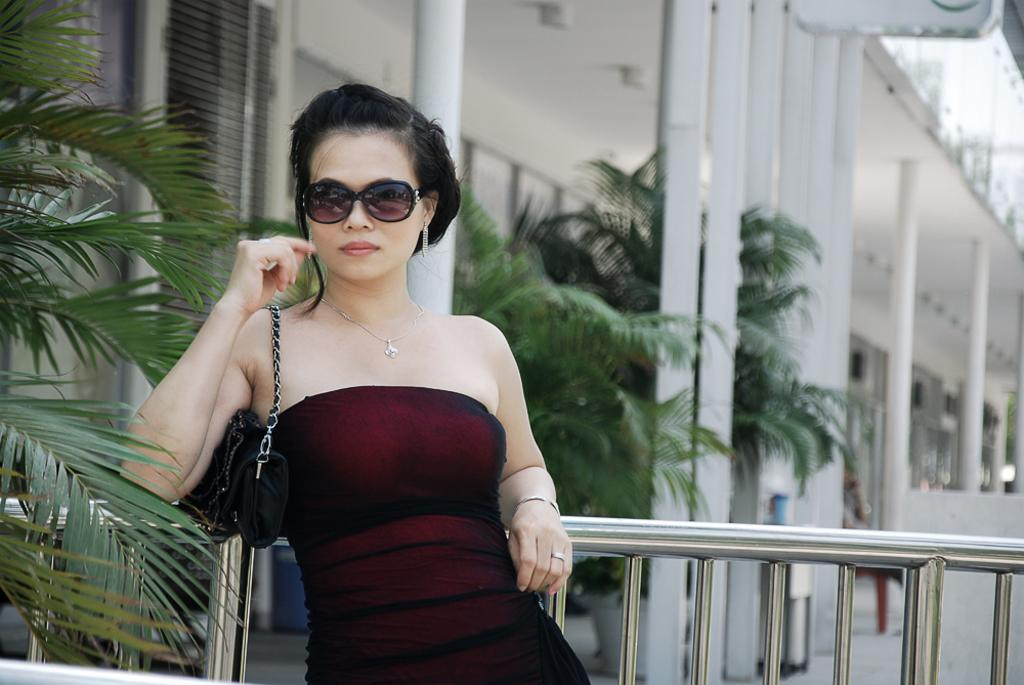What type of structure is in the image? There is a building in the image. What feature can be seen on the building? The building has windows. What natural element is present in the image? There is a tree in the image. Who is in the image? There is a woman in the image. What protective gear is the woman wearing? The woman is wearing goggles. What color is the woman's dress? The woman is wearing a red dress. What object is the woman holding? The woman is holding a black color bag. What word does the woman say to the tree in the image? There is no indication in the image that the woman is saying anything to the tree, so it cannot be determined from the picture. 